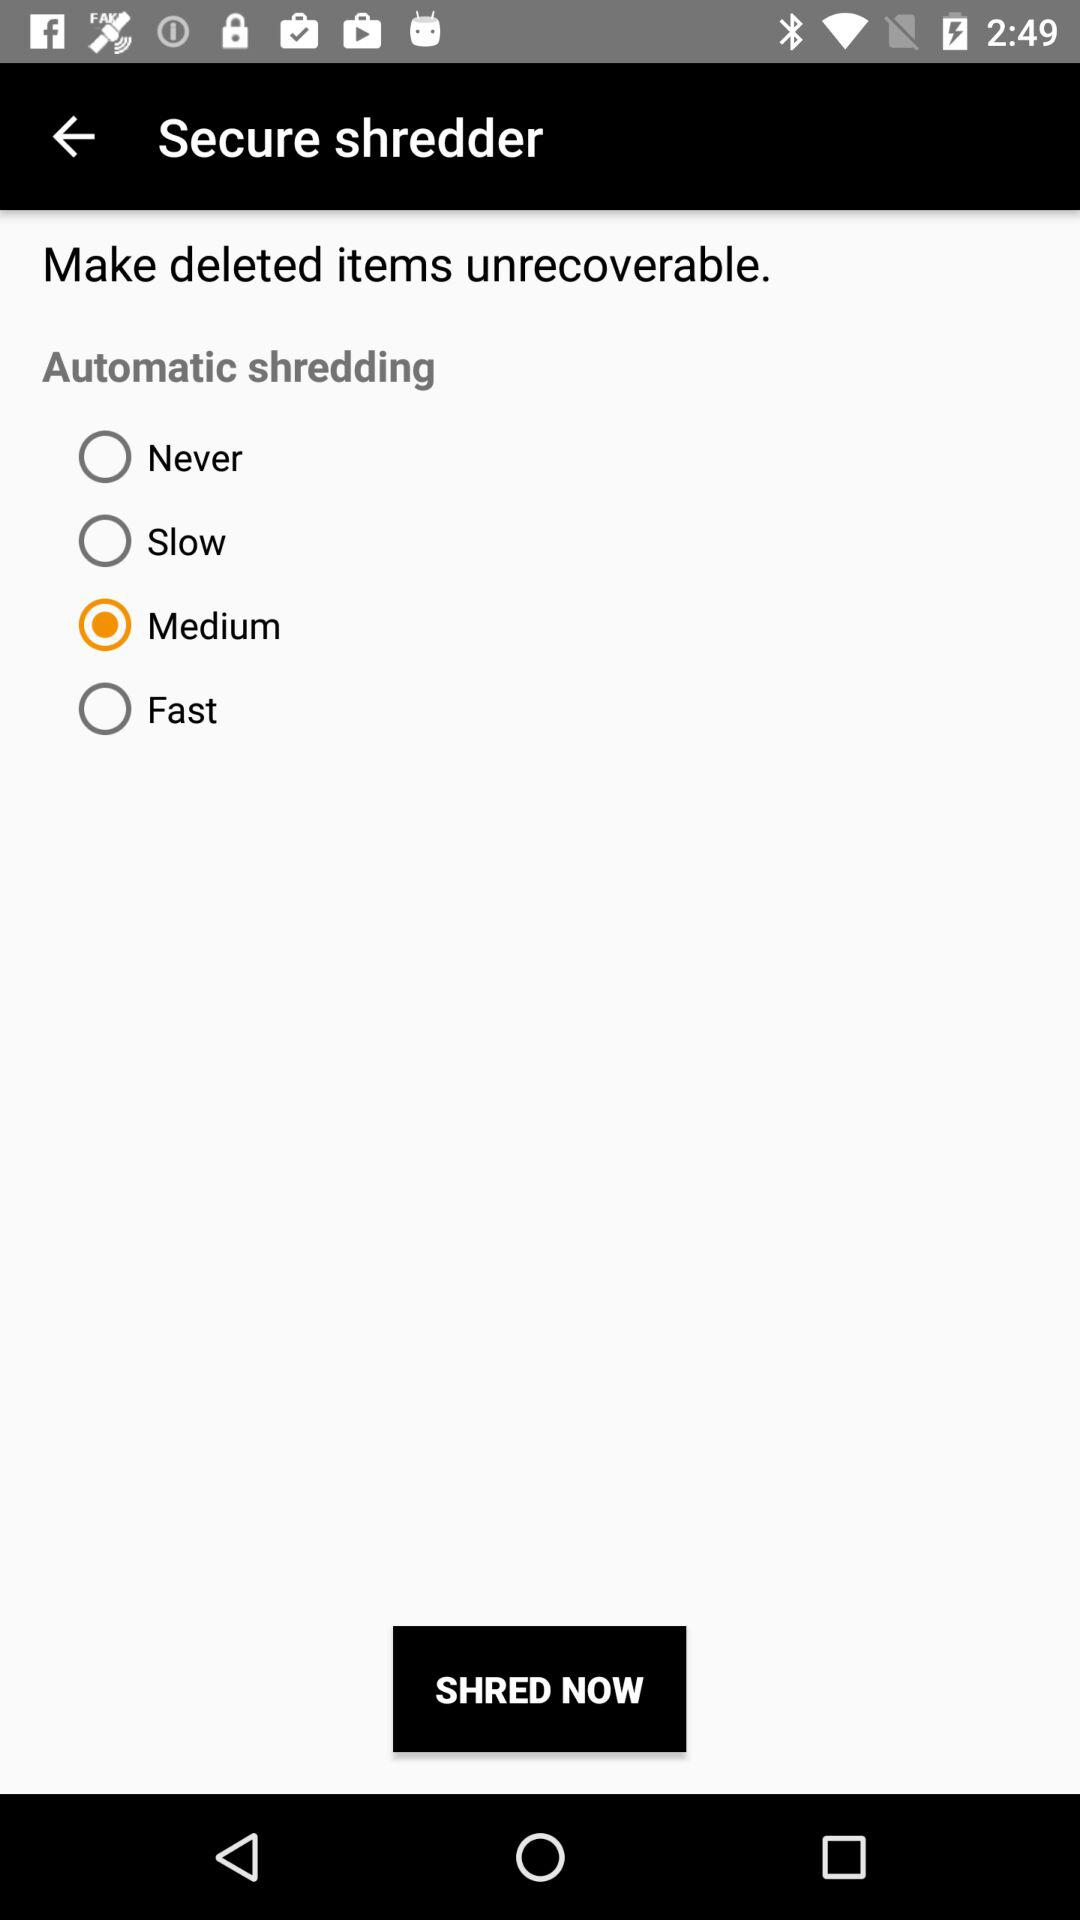Which automatic shredding has been selected? The selected automatic shredding is "Medium". 